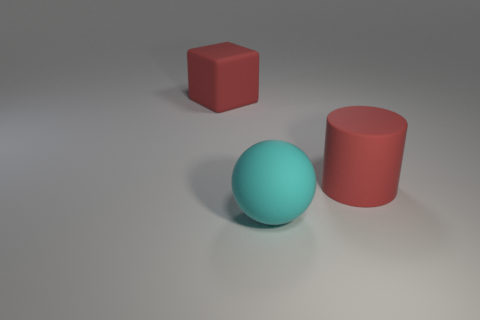Add 2 big red shiny cylinders. How many objects exist? 5 Subtract all cylinders. How many objects are left? 2 Subtract all big red cylinders. Subtract all red things. How many objects are left? 0 Add 3 rubber things. How many rubber things are left? 6 Add 1 large yellow rubber blocks. How many large yellow rubber blocks exist? 1 Subtract 0 brown balls. How many objects are left? 3 